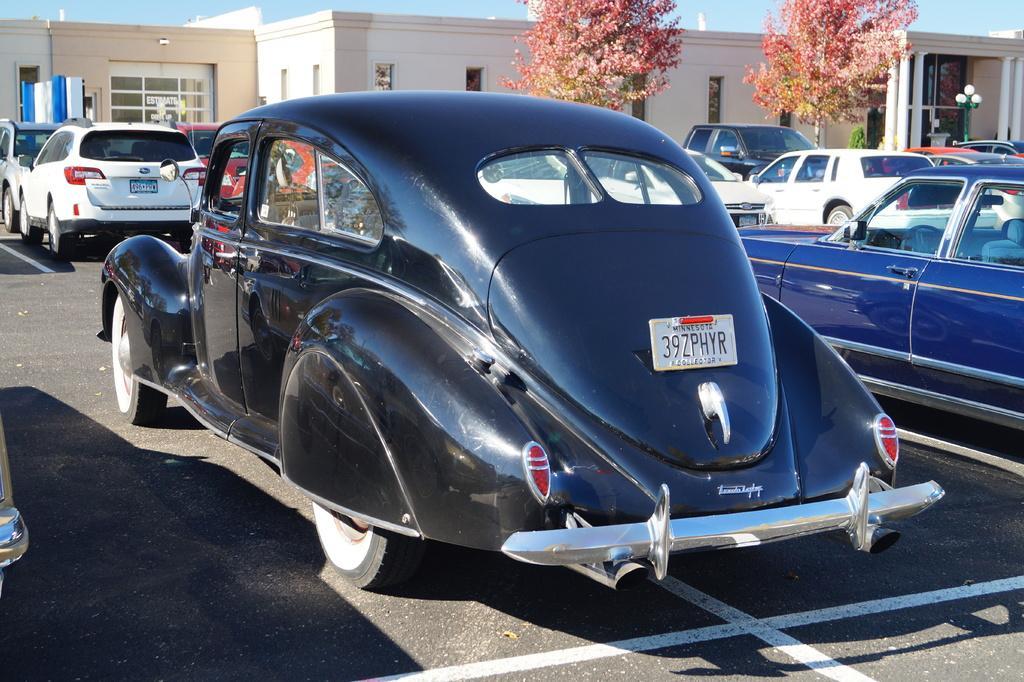How would you summarize this image in a sentence or two? In this image we can see group of vehicles parked in a parking lot. In the background, we can see a building, group of trees, pole and sky. 